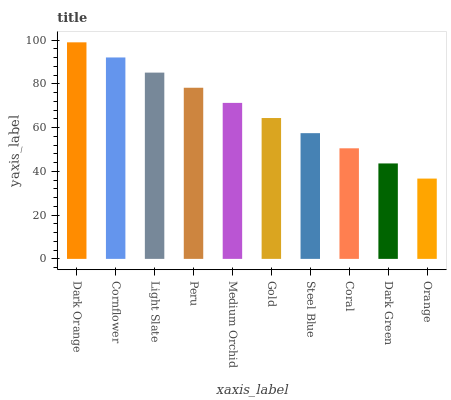Is Orange the minimum?
Answer yes or no. Yes. Is Dark Orange the maximum?
Answer yes or no. Yes. Is Cornflower the minimum?
Answer yes or no. No. Is Cornflower the maximum?
Answer yes or no. No. Is Dark Orange greater than Cornflower?
Answer yes or no. Yes. Is Cornflower less than Dark Orange?
Answer yes or no. Yes. Is Cornflower greater than Dark Orange?
Answer yes or no. No. Is Dark Orange less than Cornflower?
Answer yes or no. No. Is Medium Orchid the high median?
Answer yes or no. Yes. Is Gold the low median?
Answer yes or no. Yes. Is Dark Green the high median?
Answer yes or no. No. Is Steel Blue the low median?
Answer yes or no. No. 